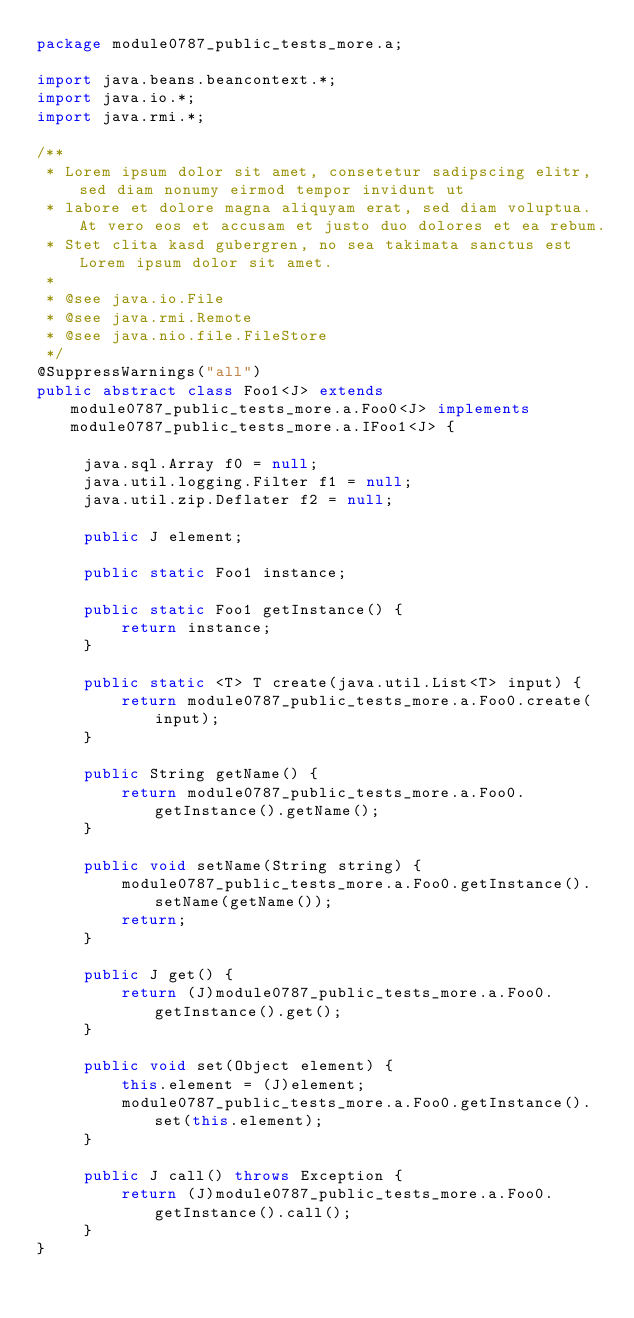<code> <loc_0><loc_0><loc_500><loc_500><_Java_>package module0787_public_tests_more.a;

import java.beans.beancontext.*;
import java.io.*;
import java.rmi.*;

/**
 * Lorem ipsum dolor sit amet, consetetur sadipscing elitr, sed diam nonumy eirmod tempor invidunt ut 
 * labore et dolore magna aliquyam erat, sed diam voluptua. At vero eos et accusam et justo duo dolores et ea rebum. 
 * Stet clita kasd gubergren, no sea takimata sanctus est Lorem ipsum dolor sit amet. 
 *
 * @see java.io.File
 * @see java.rmi.Remote
 * @see java.nio.file.FileStore
 */
@SuppressWarnings("all")
public abstract class Foo1<J> extends module0787_public_tests_more.a.Foo0<J> implements module0787_public_tests_more.a.IFoo1<J> {

	 java.sql.Array f0 = null;
	 java.util.logging.Filter f1 = null;
	 java.util.zip.Deflater f2 = null;

	 public J element;

	 public static Foo1 instance;

	 public static Foo1 getInstance() {
	 	 return instance;
	 }

	 public static <T> T create(java.util.List<T> input) {
	 	 return module0787_public_tests_more.a.Foo0.create(input);
	 }

	 public String getName() {
	 	 return module0787_public_tests_more.a.Foo0.getInstance().getName();
	 }

	 public void setName(String string) {
	 	 module0787_public_tests_more.a.Foo0.getInstance().setName(getName());
	 	 return;
	 }

	 public J get() {
	 	 return (J)module0787_public_tests_more.a.Foo0.getInstance().get();
	 }

	 public void set(Object element) {
	 	 this.element = (J)element;
	 	 module0787_public_tests_more.a.Foo0.getInstance().set(this.element);
	 }

	 public J call() throws Exception {
	 	 return (J)module0787_public_tests_more.a.Foo0.getInstance().call();
	 }
}
</code> 